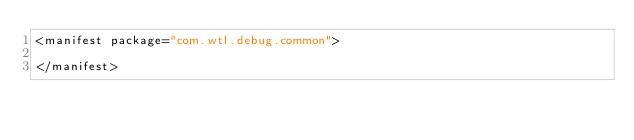<code> <loc_0><loc_0><loc_500><loc_500><_XML_><manifest package="com.wtl.debug.common">

</manifest>
</code> 